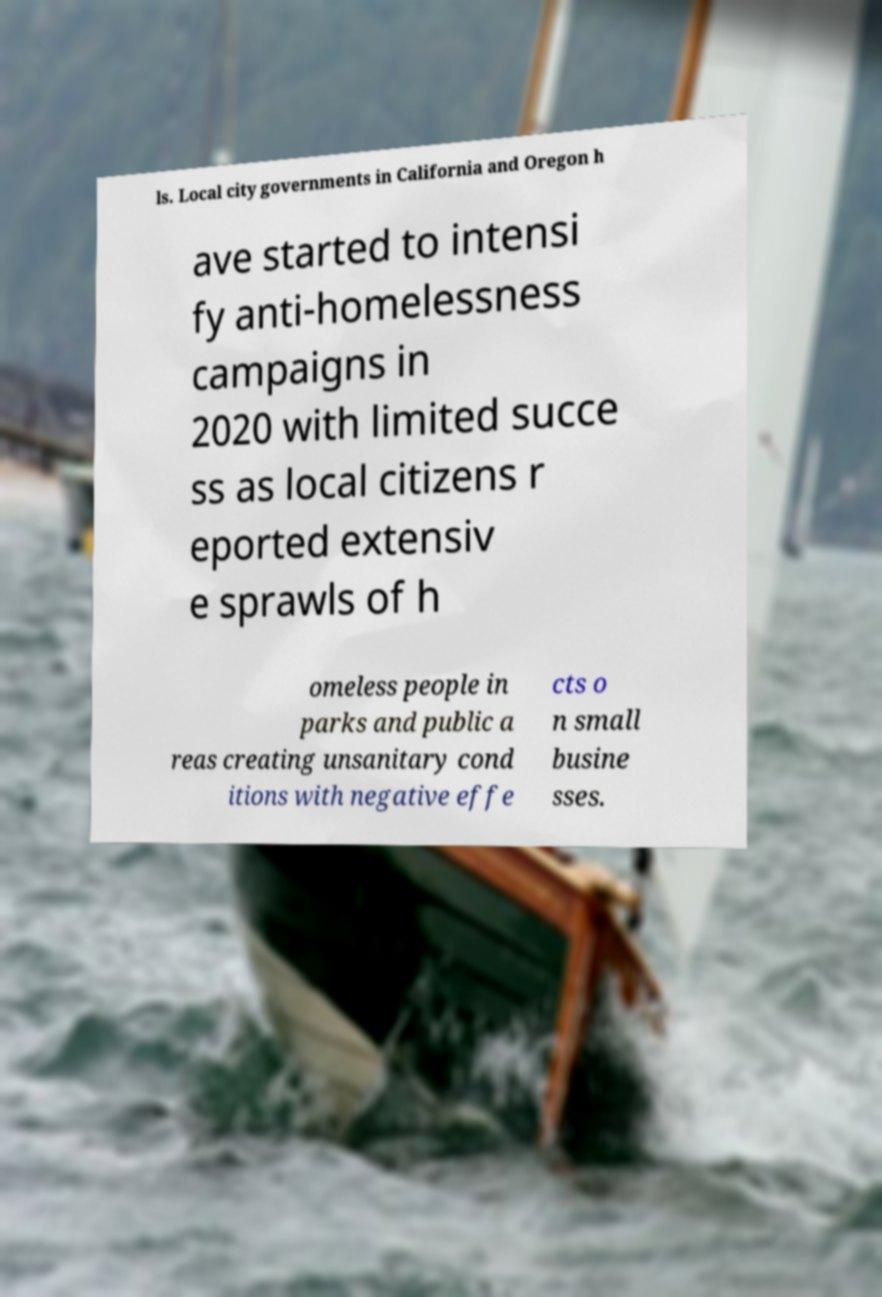Could you extract and type out the text from this image? ls. Local city governments in California and Oregon h ave started to intensi fy anti-homelessness campaigns in 2020 with limited succe ss as local citizens r eported extensiv e sprawls of h omeless people in parks and public a reas creating unsanitary cond itions with negative effe cts o n small busine sses. 